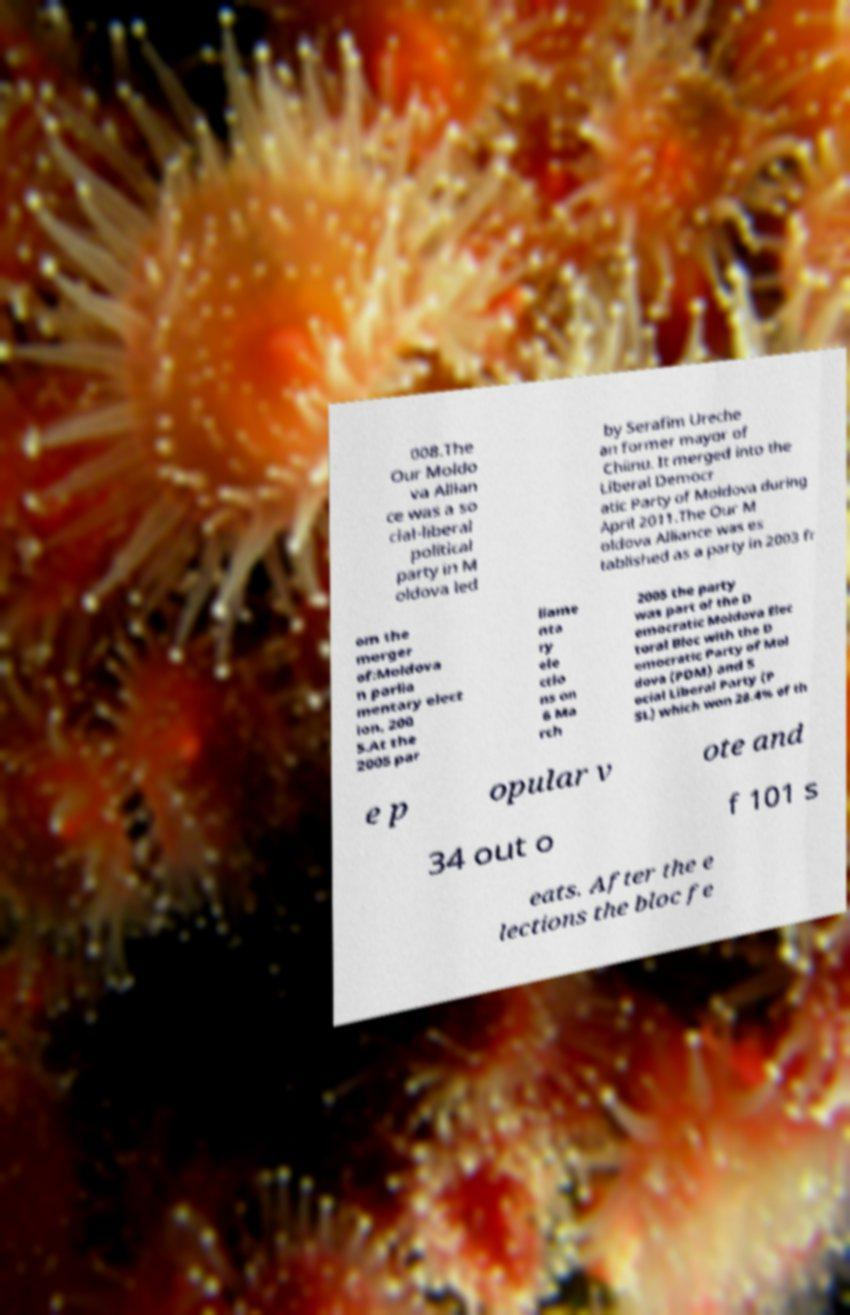What messages or text are displayed in this image? I need them in a readable, typed format. 008.The Our Moldo va Allian ce was a so cial-liberal political party in M oldova led by Serafim Ureche an former mayor of Chiinu. It merged into the Liberal Democr atic Party of Moldova during April 2011.The Our M oldova Alliance was es tablished as a party in 2003 fr om the merger of:Moldova n parlia mentary elect ion, 200 5.At the 2005 par liame nta ry ele ctio ns on 6 Ma rch 2005 the party was part of the D emocratic Moldova Elec toral Bloc with the D emocratic Party of Mol dova (PDM) and S ocial Liberal Party (P SL) which won 28.4% of th e p opular v ote and 34 out o f 101 s eats. After the e lections the bloc fe 